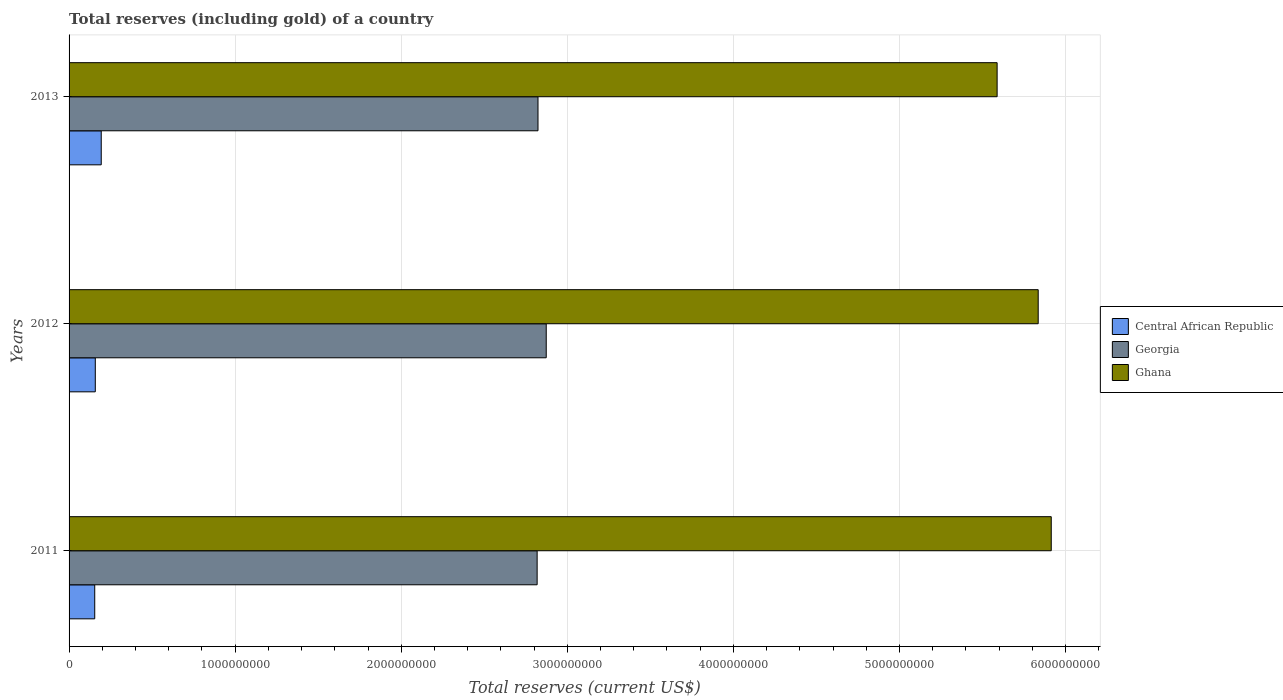How many different coloured bars are there?
Offer a terse response. 3. How many groups of bars are there?
Provide a short and direct response. 3. Are the number of bars per tick equal to the number of legend labels?
Offer a very short reply. Yes. Are the number of bars on each tick of the Y-axis equal?
Make the answer very short. Yes. How many bars are there on the 3rd tick from the bottom?
Give a very brief answer. 3. What is the label of the 3rd group of bars from the top?
Provide a succinct answer. 2011. In how many cases, is the number of bars for a given year not equal to the number of legend labels?
Ensure brevity in your answer.  0. What is the total reserves (including gold) in Ghana in 2011?
Give a very brief answer. 5.91e+09. Across all years, what is the maximum total reserves (including gold) in Ghana?
Offer a terse response. 5.91e+09. Across all years, what is the minimum total reserves (including gold) in Ghana?
Your response must be concise. 5.59e+09. In which year was the total reserves (including gold) in Ghana minimum?
Offer a very short reply. 2013. What is the total total reserves (including gold) in Ghana in the graph?
Your answer should be compact. 1.73e+1. What is the difference between the total reserves (including gold) in Georgia in 2011 and that in 2012?
Provide a short and direct response. -5.48e+07. What is the difference between the total reserves (including gold) in Central African Republic in 2013 and the total reserves (including gold) in Ghana in 2012?
Provide a succinct answer. -5.64e+09. What is the average total reserves (including gold) in Georgia per year?
Provide a short and direct response. 2.84e+09. In the year 2012, what is the difference between the total reserves (including gold) in Ghana and total reserves (including gold) in Central African Republic?
Ensure brevity in your answer.  5.68e+09. What is the ratio of the total reserves (including gold) in Ghana in 2011 to that in 2012?
Give a very brief answer. 1.01. Is the difference between the total reserves (including gold) in Ghana in 2011 and 2013 greater than the difference between the total reserves (including gold) in Central African Republic in 2011 and 2013?
Your response must be concise. Yes. What is the difference between the highest and the second highest total reserves (including gold) in Georgia?
Your answer should be compact. 4.96e+07. What is the difference between the highest and the lowest total reserves (including gold) in Central African Republic?
Ensure brevity in your answer.  3.92e+07. Is the sum of the total reserves (including gold) in Central African Republic in 2012 and 2013 greater than the maximum total reserves (including gold) in Georgia across all years?
Keep it short and to the point. No. What does the 2nd bar from the top in 2011 represents?
Provide a short and direct response. Georgia. What does the 3rd bar from the bottom in 2011 represents?
Keep it short and to the point. Ghana. Is it the case that in every year, the sum of the total reserves (including gold) in Georgia and total reserves (including gold) in Ghana is greater than the total reserves (including gold) in Central African Republic?
Ensure brevity in your answer.  Yes. How many bars are there?
Your answer should be very brief. 9. Are the values on the major ticks of X-axis written in scientific E-notation?
Make the answer very short. No. How are the legend labels stacked?
Provide a succinct answer. Vertical. What is the title of the graph?
Your response must be concise. Total reserves (including gold) of a country. What is the label or title of the X-axis?
Provide a succinct answer. Total reserves (current US$). What is the label or title of the Y-axis?
Keep it short and to the point. Years. What is the Total reserves (current US$) of Central African Republic in 2011?
Your answer should be very brief. 1.55e+08. What is the Total reserves (current US$) of Georgia in 2011?
Make the answer very short. 2.82e+09. What is the Total reserves (current US$) of Ghana in 2011?
Give a very brief answer. 5.91e+09. What is the Total reserves (current US$) of Central African Republic in 2012?
Your answer should be very brief. 1.58e+08. What is the Total reserves (current US$) of Georgia in 2012?
Ensure brevity in your answer.  2.87e+09. What is the Total reserves (current US$) of Ghana in 2012?
Provide a succinct answer. 5.84e+09. What is the Total reserves (current US$) of Central African Republic in 2013?
Your answer should be very brief. 1.94e+08. What is the Total reserves (current US$) in Georgia in 2013?
Your answer should be compact. 2.82e+09. What is the Total reserves (current US$) of Ghana in 2013?
Make the answer very short. 5.59e+09. Across all years, what is the maximum Total reserves (current US$) in Central African Republic?
Offer a very short reply. 1.94e+08. Across all years, what is the maximum Total reserves (current US$) of Georgia?
Offer a terse response. 2.87e+09. Across all years, what is the maximum Total reserves (current US$) of Ghana?
Ensure brevity in your answer.  5.91e+09. Across all years, what is the minimum Total reserves (current US$) of Central African Republic?
Your response must be concise. 1.55e+08. Across all years, what is the minimum Total reserves (current US$) in Georgia?
Offer a very short reply. 2.82e+09. Across all years, what is the minimum Total reserves (current US$) of Ghana?
Make the answer very short. 5.59e+09. What is the total Total reserves (current US$) of Central African Republic in the graph?
Give a very brief answer. 5.06e+08. What is the total Total reserves (current US$) of Georgia in the graph?
Your response must be concise. 8.51e+09. What is the total Total reserves (current US$) in Ghana in the graph?
Keep it short and to the point. 1.73e+1. What is the difference between the Total reserves (current US$) in Central African Republic in 2011 and that in 2012?
Your answer should be very brief. -3.39e+06. What is the difference between the Total reserves (current US$) in Georgia in 2011 and that in 2012?
Give a very brief answer. -5.48e+07. What is the difference between the Total reserves (current US$) of Ghana in 2011 and that in 2012?
Your answer should be compact. 7.85e+07. What is the difference between the Total reserves (current US$) in Central African Republic in 2011 and that in 2013?
Give a very brief answer. -3.92e+07. What is the difference between the Total reserves (current US$) in Georgia in 2011 and that in 2013?
Ensure brevity in your answer.  -5.19e+06. What is the difference between the Total reserves (current US$) of Ghana in 2011 and that in 2013?
Provide a succinct answer. 3.26e+08. What is the difference between the Total reserves (current US$) in Central African Republic in 2012 and that in 2013?
Ensure brevity in your answer.  -3.58e+07. What is the difference between the Total reserves (current US$) in Georgia in 2012 and that in 2013?
Your answer should be very brief. 4.96e+07. What is the difference between the Total reserves (current US$) in Ghana in 2012 and that in 2013?
Ensure brevity in your answer.  2.47e+08. What is the difference between the Total reserves (current US$) of Central African Republic in 2011 and the Total reserves (current US$) of Georgia in 2012?
Your response must be concise. -2.72e+09. What is the difference between the Total reserves (current US$) in Central African Republic in 2011 and the Total reserves (current US$) in Ghana in 2012?
Ensure brevity in your answer.  -5.68e+09. What is the difference between the Total reserves (current US$) in Georgia in 2011 and the Total reserves (current US$) in Ghana in 2012?
Provide a short and direct response. -3.02e+09. What is the difference between the Total reserves (current US$) of Central African Republic in 2011 and the Total reserves (current US$) of Georgia in 2013?
Your answer should be compact. -2.67e+09. What is the difference between the Total reserves (current US$) in Central African Republic in 2011 and the Total reserves (current US$) in Ghana in 2013?
Keep it short and to the point. -5.43e+09. What is the difference between the Total reserves (current US$) in Georgia in 2011 and the Total reserves (current US$) in Ghana in 2013?
Ensure brevity in your answer.  -2.77e+09. What is the difference between the Total reserves (current US$) of Central African Republic in 2012 and the Total reserves (current US$) of Georgia in 2013?
Give a very brief answer. -2.67e+09. What is the difference between the Total reserves (current US$) in Central African Republic in 2012 and the Total reserves (current US$) in Ghana in 2013?
Ensure brevity in your answer.  -5.43e+09. What is the difference between the Total reserves (current US$) in Georgia in 2012 and the Total reserves (current US$) in Ghana in 2013?
Provide a succinct answer. -2.71e+09. What is the average Total reserves (current US$) in Central African Republic per year?
Give a very brief answer. 1.69e+08. What is the average Total reserves (current US$) of Georgia per year?
Keep it short and to the point. 2.84e+09. What is the average Total reserves (current US$) of Ghana per year?
Ensure brevity in your answer.  5.78e+09. In the year 2011, what is the difference between the Total reserves (current US$) of Central African Republic and Total reserves (current US$) of Georgia?
Provide a short and direct response. -2.66e+09. In the year 2011, what is the difference between the Total reserves (current US$) of Central African Republic and Total reserves (current US$) of Ghana?
Provide a succinct answer. -5.76e+09. In the year 2011, what is the difference between the Total reserves (current US$) in Georgia and Total reserves (current US$) in Ghana?
Give a very brief answer. -3.10e+09. In the year 2012, what is the difference between the Total reserves (current US$) of Central African Republic and Total reserves (current US$) of Georgia?
Your answer should be very brief. -2.72e+09. In the year 2012, what is the difference between the Total reserves (current US$) of Central African Republic and Total reserves (current US$) of Ghana?
Make the answer very short. -5.68e+09. In the year 2012, what is the difference between the Total reserves (current US$) in Georgia and Total reserves (current US$) in Ghana?
Your response must be concise. -2.96e+09. In the year 2013, what is the difference between the Total reserves (current US$) of Central African Republic and Total reserves (current US$) of Georgia?
Your answer should be compact. -2.63e+09. In the year 2013, what is the difference between the Total reserves (current US$) in Central African Republic and Total reserves (current US$) in Ghana?
Ensure brevity in your answer.  -5.39e+09. In the year 2013, what is the difference between the Total reserves (current US$) in Georgia and Total reserves (current US$) in Ghana?
Provide a succinct answer. -2.76e+09. What is the ratio of the Total reserves (current US$) in Central African Republic in 2011 to that in 2012?
Offer a terse response. 0.98. What is the ratio of the Total reserves (current US$) in Georgia in 2011 to that in 2012?
Provide a succinct answer. 0.98. What is the ratio of the Total reserves (current US$) of Ghana in 2011 to that in 2012?
Give a very brief answer. 1.01. What is the ratio of the Total reserves (current US$) of Central African Republic in 2011 to that in 2013?
Provide a short and direct response. 0.8. What is the ratio of the Total reserves (current US$) of Ghana in 2011 to that in 2013?
Make the answer very short. 1.06. What is the ratio of the Total reserves (current US$) in Central African Republic in 2012 to that in 2013?
Keep it short and to the point. 0.82. What is the ratio of the Total reserves (current US$) in Georgia in 2012 to that in 2013?
Your answer should be compact. 1.02. What is the ratio of the Total reserves (current US$) of Ghana in 2012 to that in 2013?
Your answer should be compact. 1.04. What is the difference between the highest and the second highest Total reserves (current US$) in Central African Republic?
Provide a succinct answer. 3.58e+07. What is the difference between the highest and the second highest Total reserves (current US$) of Georgia?
Your answer should be very brief. 4.96e+07. What is the difference between the highest and the second highest Total reserves (current US$) of Ghana?
Make the answer very short. 7.85e+07. What is the difference between the highest and the lowest Total reserves (current US$) in Central African Republic?
Provide a succinct answer. 3.92e+07. What is the difference between the highest and the lowest Total reserves (current US$) of Georgia?
Provide a succinct answer. 5.48e+07. What is the difference between the highest and the lowest Total reserves (current US$) of Ghana?
Your answer should be very brief. 3.26e+08. 